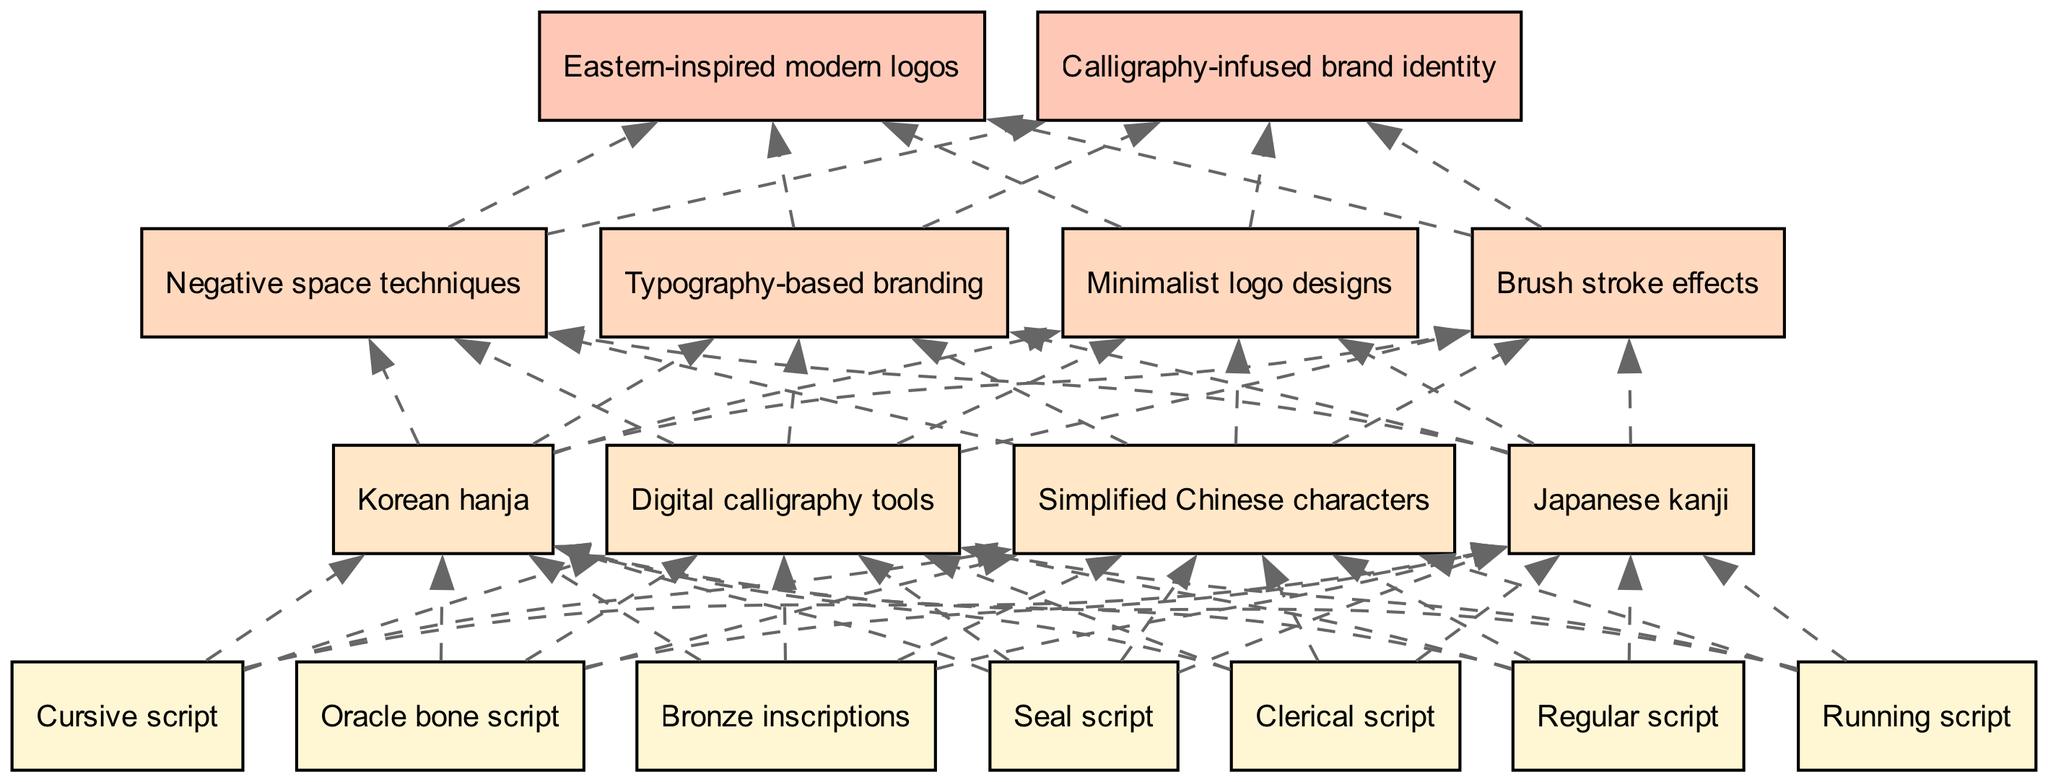What are the base elements in the diagram? The diagram lists seven base elements at the bottom level, which are: Oracle bone script, Bronze inscriptions, Seal script, Clerical script, Regular script, Running script, and Cursive script.
Answer: Oracle bone script, Bronze inscriptions, Seal script, Clerical script, Regular script, Running script, Cursive script How many intermediate elements are there? There are four intermediate elements shown in the diagram, which are Simplified Chinese characters, Japanese kanji, Korean hanja, and Digital calligraphy tools.
Answer: 4 Which advanced element follows "Brush stroke effects"? According to the diagram, the advanced element that follows "Brush stroke effects" is "Negative space techniques".
Answer: Negative space techniques What type of relationship exists between "Cursive script" and "Minimalist logo designs"? The relationship is a dashed edge, indicating a conceptual link where "Cursive script" influences or contributes to the design of "Minimalist logo designs".
Answer: Dashed edge What is the top element in the diagram? The top element represents the ultimate application of the previous styles, which is "Eastern-inspired modern logos".
Answer: Eastern-inspired modern logos Which base element directly influences Japanese kanji? In the diagram, the intermediate element "Japanese kanji" is influenced by the base elements, but specifically, it derives from Regular script and Clerical script.
Answer: Regular script, Clerical script How many total nodes are depicted in the diagram? The total number of nodes includes 7 base elements, 4 intermediate elements, 4 advanced elements, and 2 top elements, which equates to 17 nodes overall.
Answer: 17 What do the dashed edges indicate in this diagram? The dashed edges signify a conceptual relationship or influence between the different elements, representing how earlier calligraphy styles impact modern design approaches and applications.
Answer: Conceptual influence 